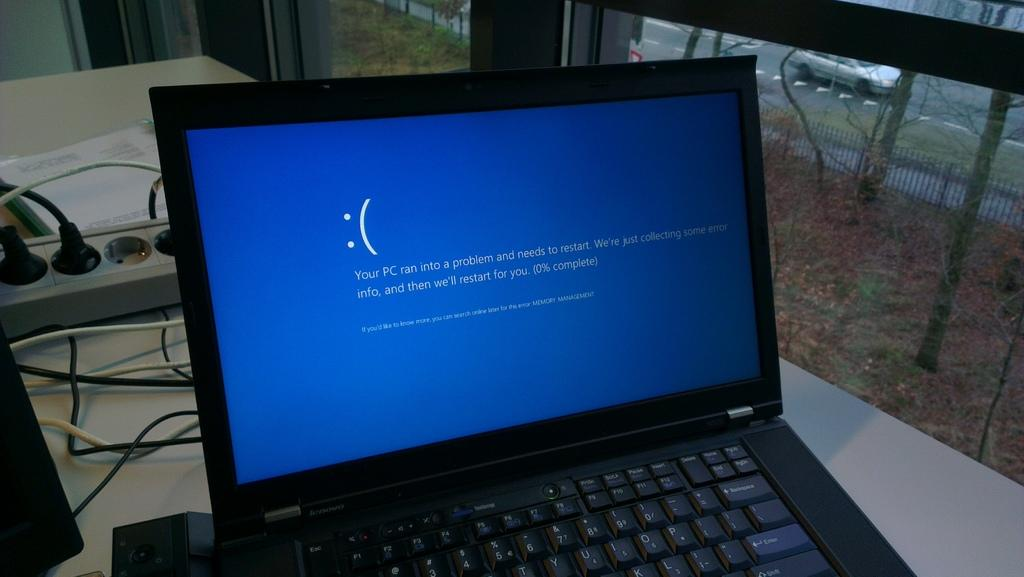<image>
Write a terse but informative summary of the picture. A blue restart page is displayed on a laptop, 